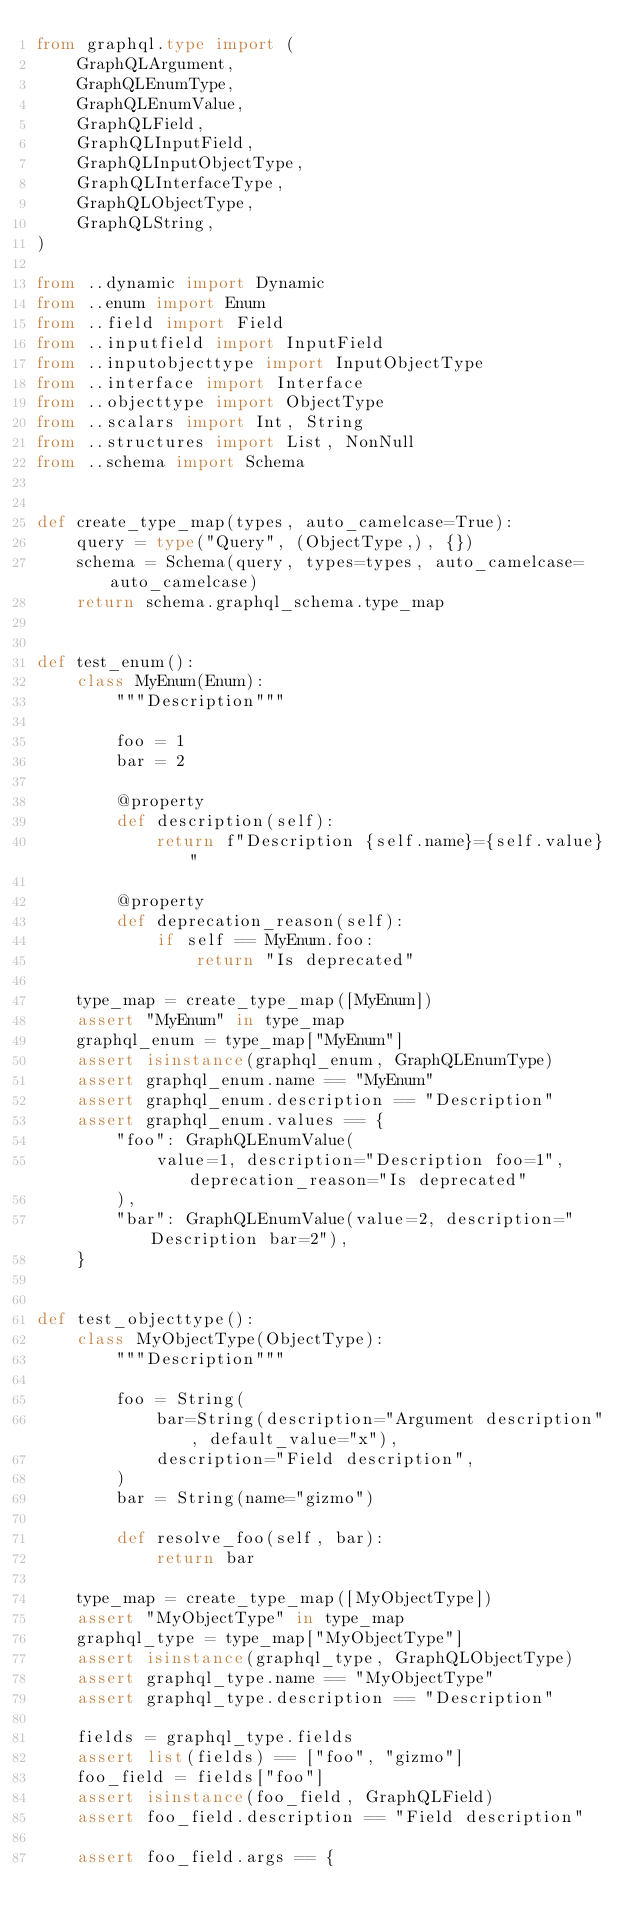<code> <loc_0><loc_0><loc_500><loc_500><_Python_>from graphql.type import (
    GraphQLArgument,
    GraphQLEnumType,
    GraphQLEnumValue,
    GraphQLField,
    GraphQLInputField,
    GraphQLInputObjectType,
    GraphQLInterfaceType,
    GraphQLObjectType,
    GraphQLString,
)

from ..dynamic import Dynamic
from ..enum import Enum
from ..field import Field
from ..inputfield import InputField
from ..inputobjecttype import InputObjectType
from ..interface import Interface
from ..objecttype import ObjectType
from ..scalars import Int, String
from ..structures import List, NonNull
from ..schema import Schema


def create_type_map(types, auto_camelcase=True):
    query = type("Query", (ObjectType,), {})
    schema = Schema(query, types=types, auto_camelcase=auto_camelcase)
    return schema.graphql_schema.type_map


def test_enum():
    class MyEnum(Enum):
        """Description"""

        foo = 1
        bar = 2

        @property
        def description(self):
            return f"Description {self.name}={self.value}"

        @property
        def deprecation_reason(self):
            if self == MyEnum.foo:
                return "Is deprecated"

    type_map = create_type_map([MyEnum])
    assert "MyEnum" in type_map
    graphql_enum = type_map["MyEnum"]
    assert isinstance(graphql_enum, GraphQLEnumType)
    assert graphql_enum.name == "MyEnum"
    assert graphql_enum.description == "Description"
    assert graphql_enum.values == {
        "foo": GraphQLEnumValue(
            value=1, description="Description foo=1", deprecation_reason="Is deprecated"
        ),
        "bar": GraphQLEnumValue(value=2, description="Description bar=2"),
    }


def test_objecttype():
    class MyObjectType(ObjectType):
        """Description"""

        foo = String(
            bar=String(description="Argument description", default_value="x"),
            description="Field description",
        )
        bar = String(name="gizmo")

        def resolve_foo(self, bar):
            return bar

    type_map = create_type_map([MyObjectType])
    assert "MyObjectType" in type_map
    graphql_type = type_map["MyObjectType"]
    assert isinstance(graphql_type, GraphQLObjectType)
    assert graphql_type.name == "MyObjectType"
    assert graphql_type.description == "Description"

    fields = graphql_type.fields
    assert list(fields) == ["foo", "gizmo"]
    foo_field = fields["foo"]
    assert isinstance(foo_field, GraphQLField)
    assert foo_field.description == "Field description"

    assert foo_field.args == {</code> 